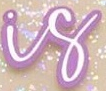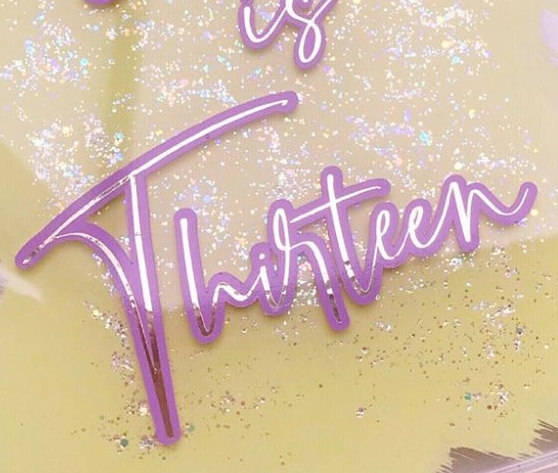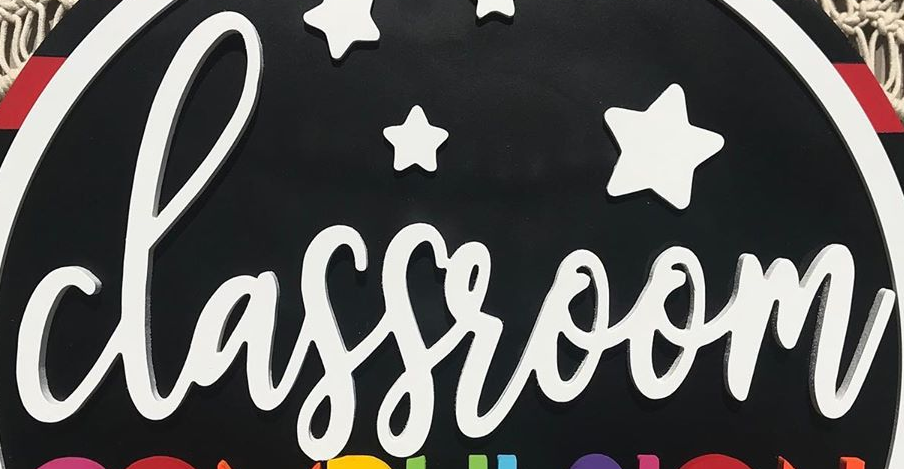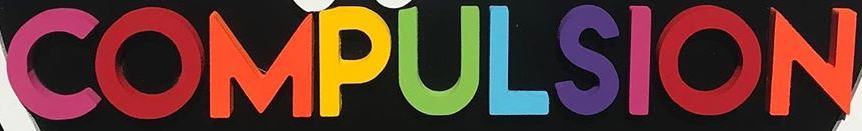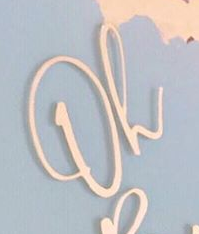Identify the words shown in these images in order, separated by a semicolon. is; Thirteen; classroom; COMPULSION; Oh 